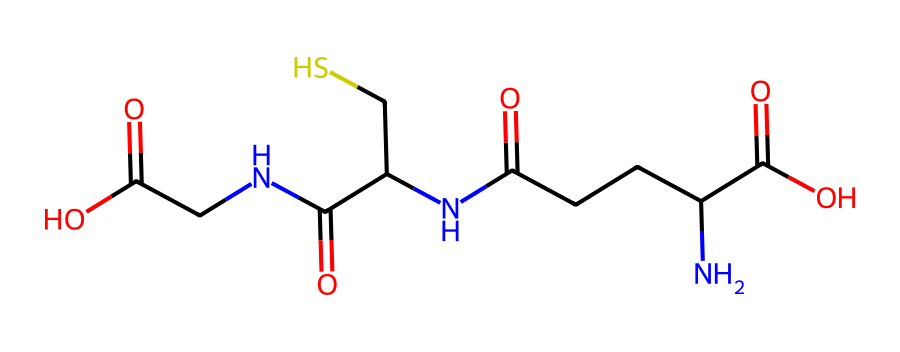what is the molecular formula of this compound? To determine the molecular formula, we analyze the SMILES representation. The atoms present include carbon (C), nitrogen (N), oxygen (O), and sulfur (S). Counting them, we find: 8 carbon atoms, 2 nitrogen atoms, 5 oxygen atoms, and 1 sulfur atom. Therefore, the molecular formula is C8H14N2O5S.
Answer: C8H14N2O5S how many nitrogen atoms are in this molecule? By examining the SPIMLES, we identify the nitrogen atoms represented by the letter 'N'. There are two instances of 'N' in the structure, indicating that there are 2 nitrogen atoms in this molecule.
Answer: 2 which functional group is primarily responsible for the antioxidant properties of this compound? The presence of thiol (-SH) group, which is represented in the SMILES as a sulfur atom connected to a carbon, confers antioxidant properties due to its ability to donate electrons and neutralize free radicals. This is critical in the detoxification process.
Answer: thiol how many carbonyl groups are present? The carbonyl groups are characterized by the presence of the C=O bond. In the given SMILES, there are three occurrences of a C=O structure, indicating the presence of 3 carbonyl groups.
Answer: 3 is this structure a simple imide or a complex one? A simple imide consists of a nitrogen atom between two carbonyl groups. In this structure, there are multiple amino acids and additional functionalities like thiol and carboxyl groups, indicating that it is a complex molecule rather than a simple imide.
Answer: complex how many carboxylic acid groups are present in the structure? Carboxylic acid groups are identified by the -COOH functionality. In the SMILES representation, there are two instances of -COOH, showing that there are two carboxylic acid groups in the structure.
Answer: 2 